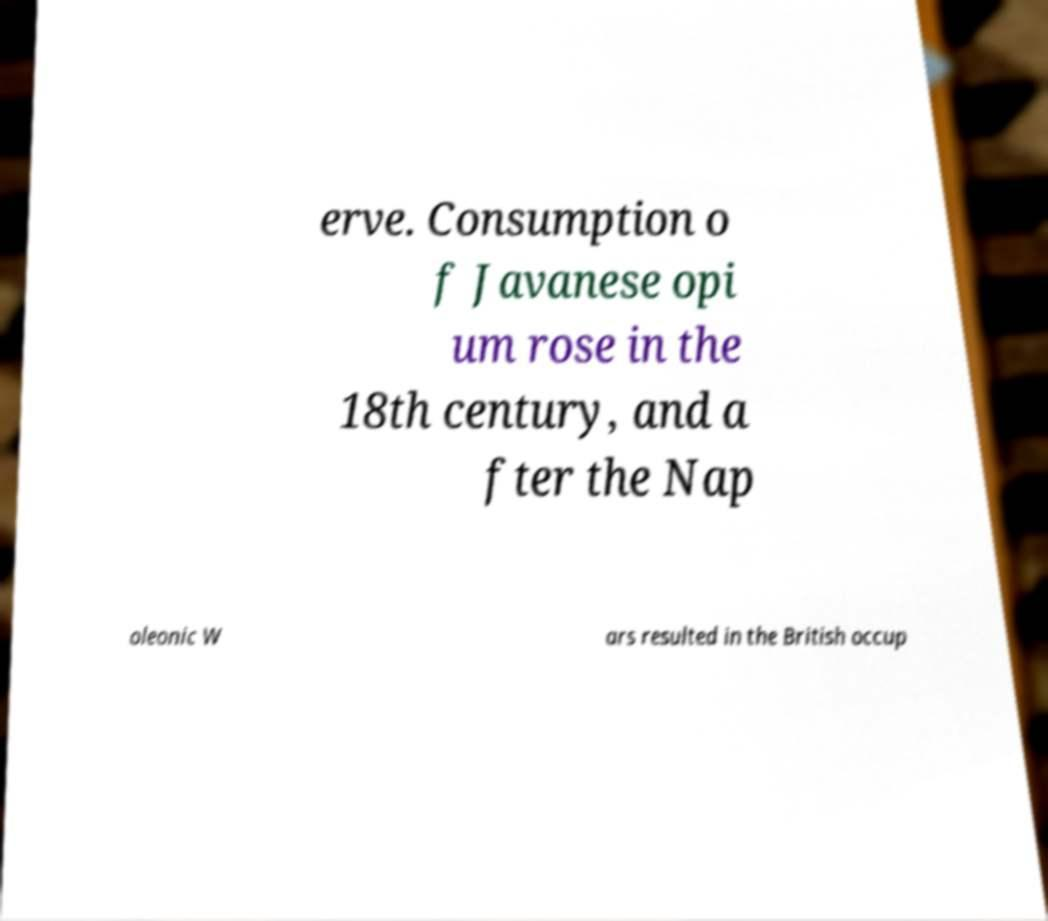Please read and relay the text visible in this image. What does it say? erve. Consumption o f Javanese opi um rose in the 18th century, and a fter the Nap oleonic W ars resulted in the British occup 